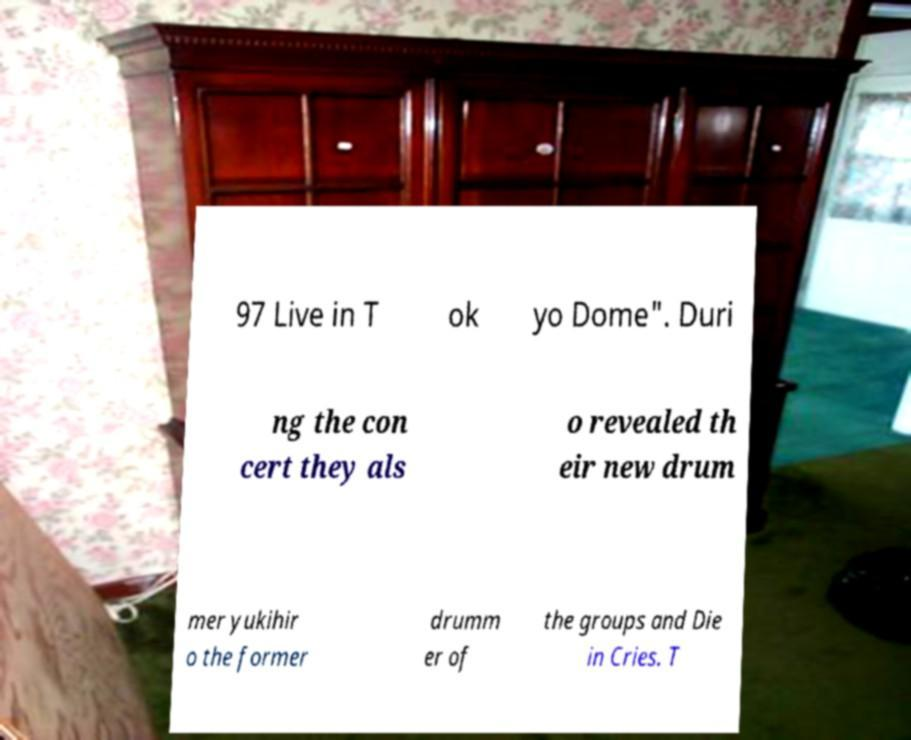There's text embedded in this image that I need extracted. Can you transcribe it verbatim? 97 Live in T ok yo Dome". Duri ng the con cert they als o revealed th eir new drum mer yukihir o the former drumm er of the groups and Die in Cries. T 